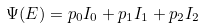<formula> <loc_0><loc_0><loc_500><loc_500>\Psi ( E ) = p _ { 0 } I _ { 0 } + p _ { 1 } I _ { 1 } + p _ { 2 } I _ { 2 }</formula> 